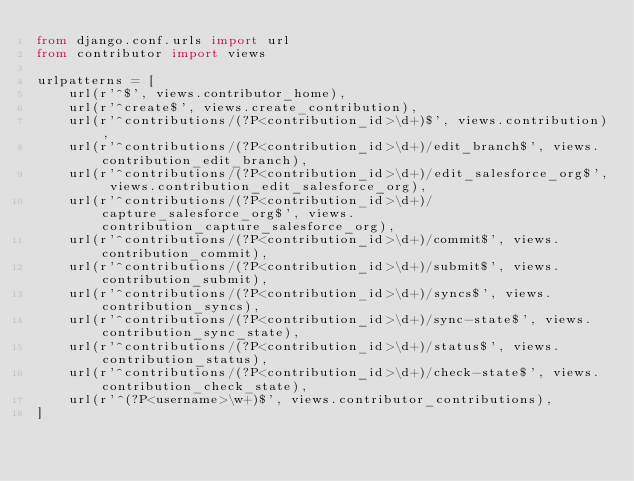<code> <loc_0><loc_0><loc_500><loc_500><_Python_>from django.conf.urls import url
from contributor import views

urlpatterns = [
    url(r'^$', views.contributor_home),
    url(r'^create$', views.create_contribution),
    url(r'^contributions/(?P<contribution_id>\d+)$', views.contribution),
    url(r'^contributions/(?P<contribution_id>\d+)/edit_branch$', views.contribution_edit_branch),
    url(r'^contributions/(?P<contribution_id>\d+)/edit_salesforce_org$', views.contribution_edit_salesforce_org),
    url(r'^contributions/(?P<contribution_id>\d+)/capture_salesforce_org$', views.contribution_capture_salesforce_org),
    url(r'^contributions/(?P<contribution_id>\d+)/commit$', views.contribution_commit),
    url(r'^contributions/(?P<contribution_id>\d+)/submit$', views.contribution_submit),
    url(r'^contributions/(?P<contribution_id>\d+)/syncs$', views.contribution_syncs),
    url(r'^contributions/(?P<contribution_id>\d+)/sync-state$', views.contribution_sync_state),
    url(r'^contributions/(?P<contribution_id>\d+)/status$', views.contribution_status),
    url(r'^contributions/(?P<contribution_id>\d+)/check-state$', views.contribution_check_state),
    url(r'^(?P<username>\w+)$', views.contributor_contributions),
]
</code> 